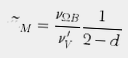<formula> <loc_0><loc_0><loc_500><loc_500>\widetilde { m } _ { M } = \frac { \nu _ { \Omega B } } { \nu ^ { \prime } _ { V } } \frac { 1 } { 2 - d }</formula> 